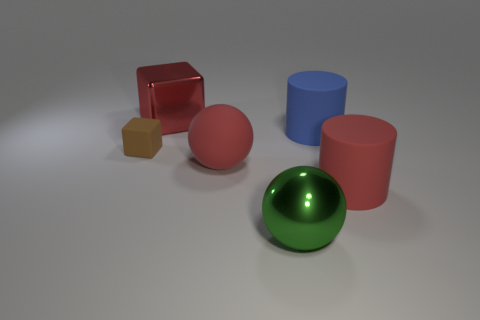What number of balls are either small brown rubber objects or blue rubber objects?
Your response must be concise. 0. How many tiny gray matte cubes are there?
Provide a short and direct response. 0. There is a blue rubber object; is its shape the same as the metal object in front of the tiny cube?
Provide a succinct answer. No. There is a cube that is the same color as the rubber ball; what is its size?
Provide a succinct answer. Large. How many things are tiny gray metal objects or green metallic things?
Your answer should be very brief. 1. There is a large metal thing behind the big red matte thing that is on the left side of the big red rubber cylinder; what shape is it?
Provide a succinct answer. Cube. Is the shape of the large metallic thing that is in front of the red rubber cylinder the same as  the blue rubber object?
Keep it short and to the point. No. What size is the block that is made of the same material as the big red cylinder?
Your answer should be compact. Small. What number of things are either spheres to the right of the metal block or rubber objects that are on the left side of the large red cylinder?
Your response must be concise. 4. Are there the same number of red shiny blocks that are to the left of the brown matte object and blue objects that are to the left of the red rubber cylinder?
Your answer should be compact. No. 